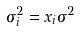Convert formula to latex. <formula><loc_0><loc_0><loc_500><loc_500>\sigma _ { i } ^ { 2 } = x _ { i } \sigma ^ { 2 }</formula> 